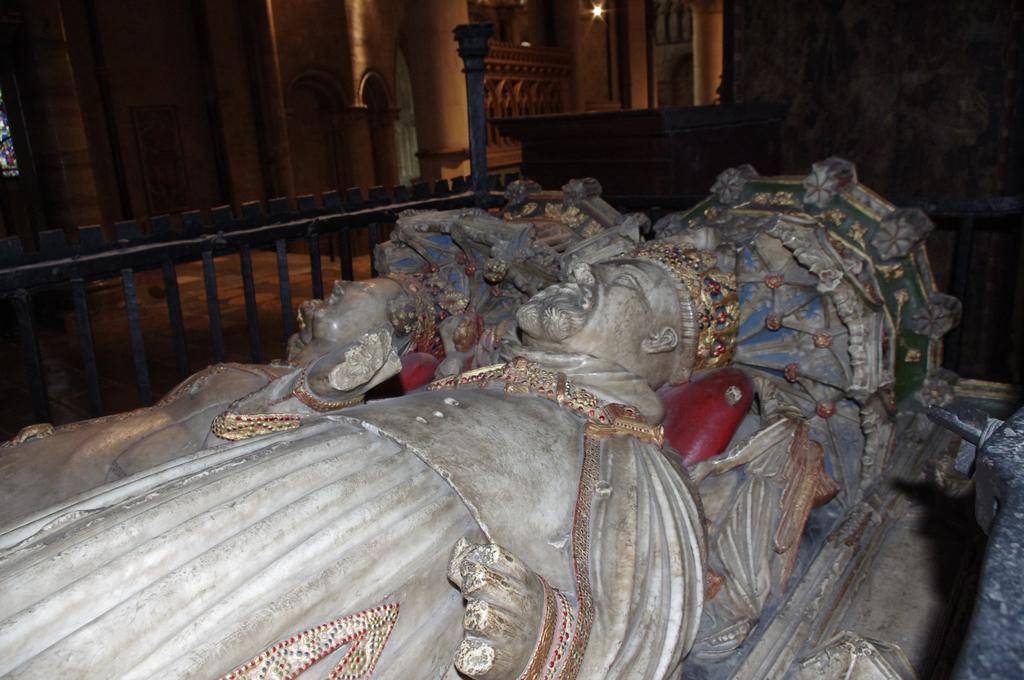Can you describe this image briefly? In the background we can see pillars, light, wall and floor. In this picture we can see a railing and statues. 